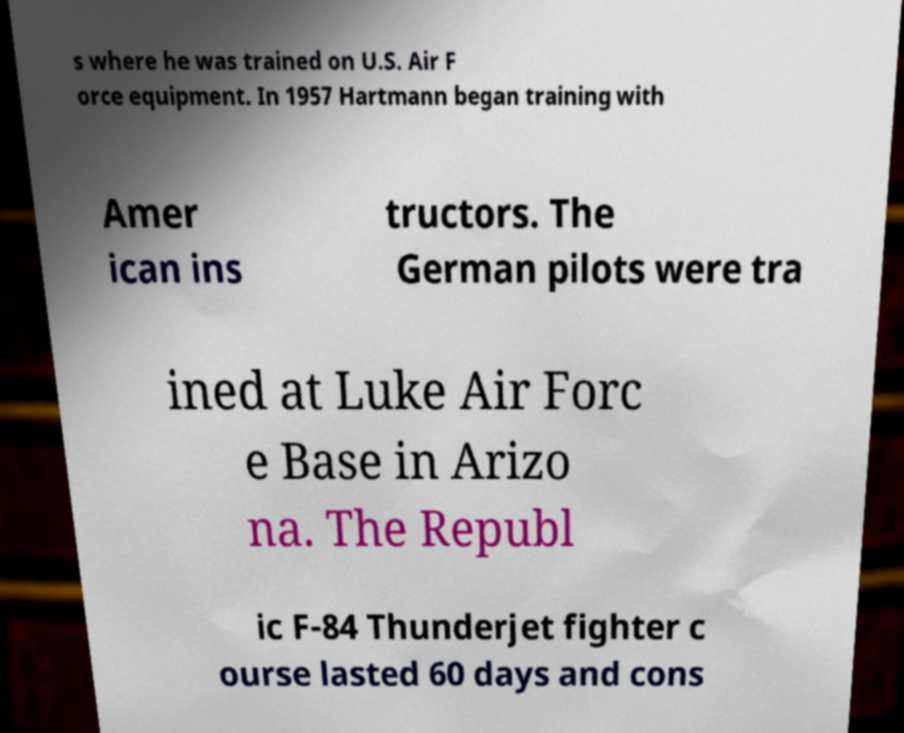Could you extract and type out the text from this image? s where he was trained on U.S. Air F orce equipment. In 1957 Hartmann began training with Amer ican ins tructors. The German pilots were tra ined at Luke Air Forc e Base in Arizo na. The Republ ic F-84 Thunderjet fighter c ourse lasted 60 days and cons 